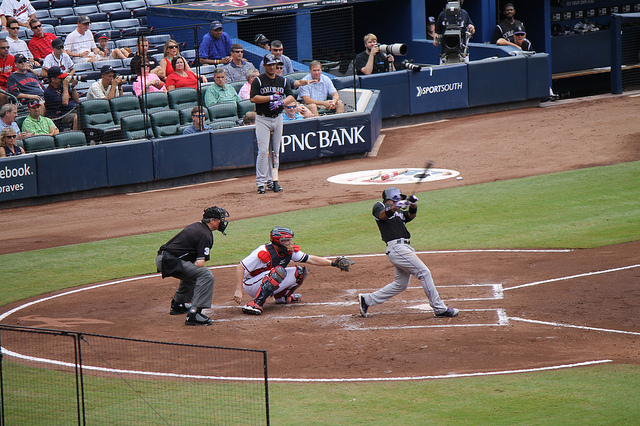What is happening in the image, and can you explain the rules of the sport being played? The image captures a moment from a baseball game. The batter has just swung at the pitch, and everyone's attention is on the trajectory of the ball. Baseball involves two teams taking turns to bat and field. When batting, the team tries to score runs by hitting the ball thrown by the pitcher and running across four bases arranged at the corners of a 90-foot diamond. The fielding team aims to get the batters out through various means like catching a hit ball before it touches the ground or touching a base with the ball before the runner arrives. 